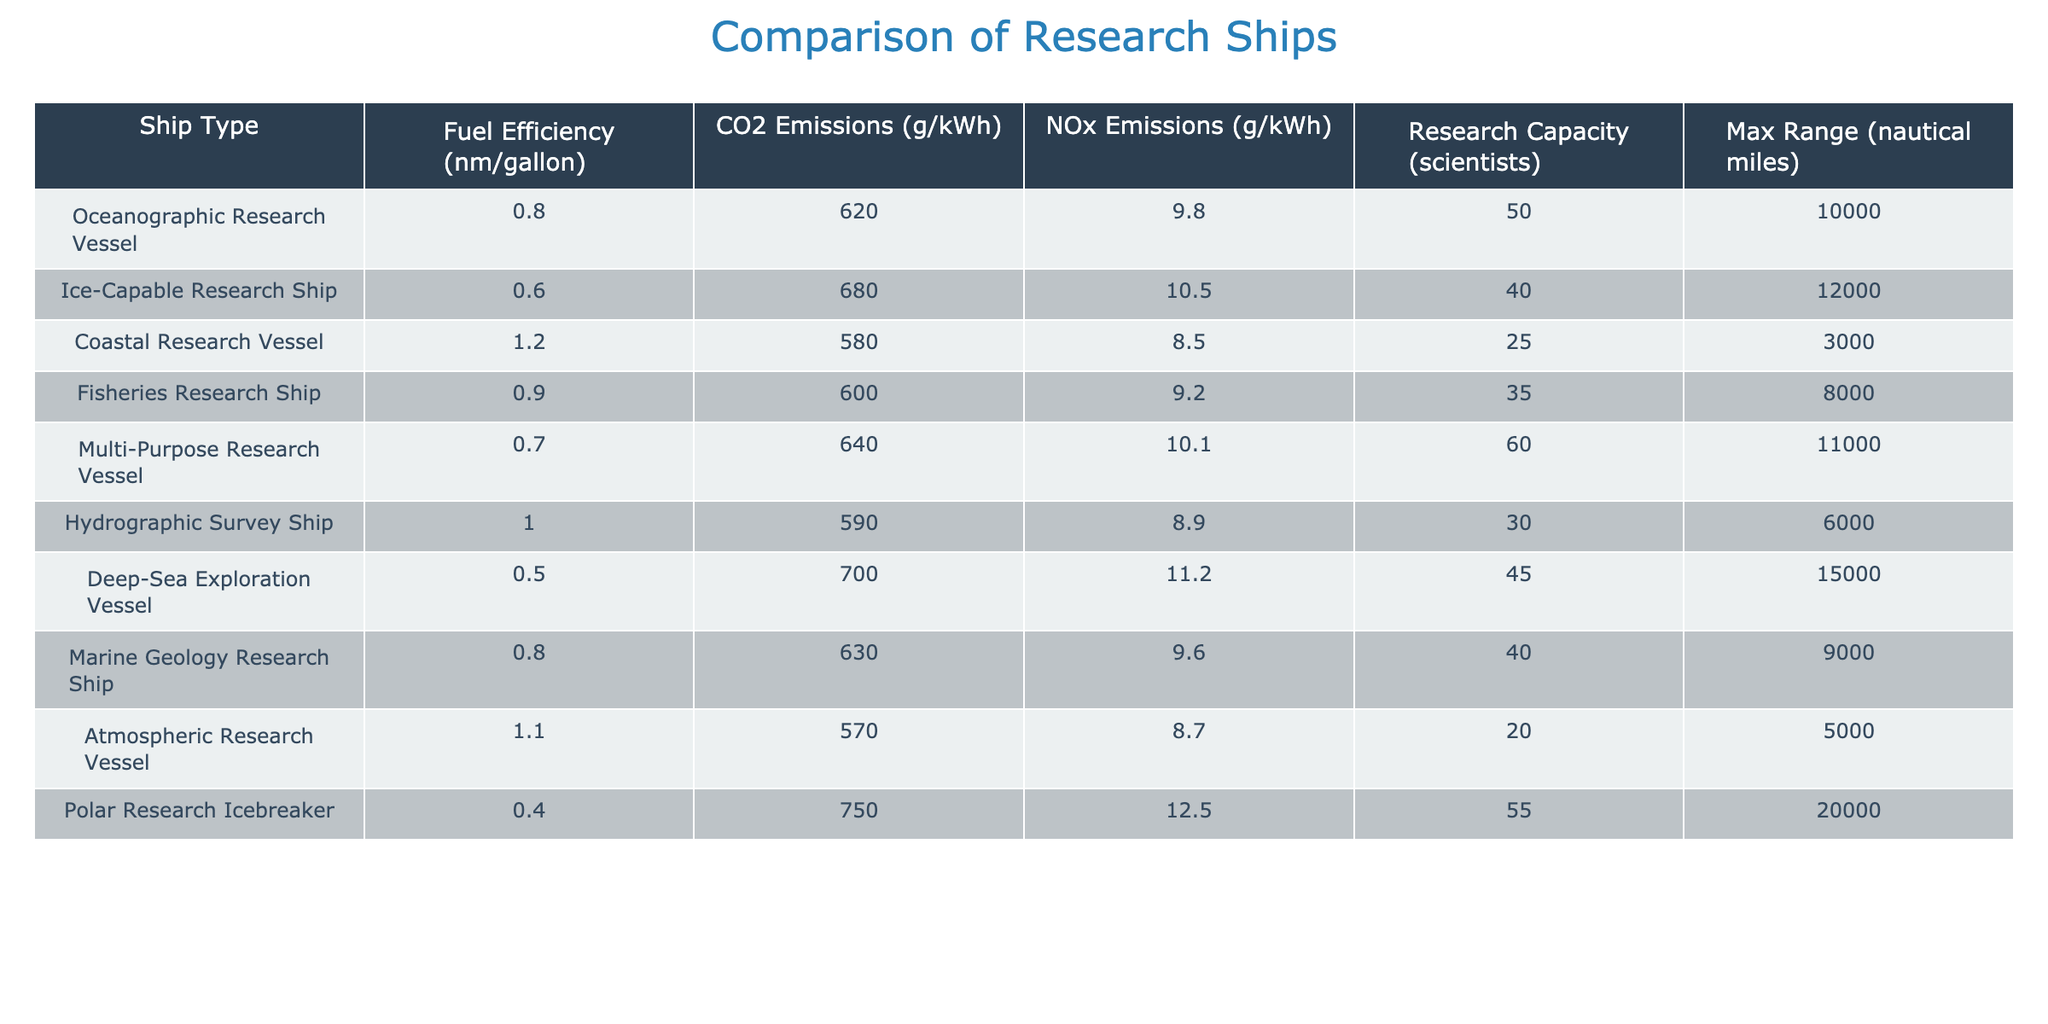What is the fuel efficiency of the Deep-Sea Exploration Vessel? The table indicates that the fuel efficiency of the Deep-Sea Exploration Vessel is 0.5 nm/gallon.
Answer: 0.5 nm/gallon Which research ship has the highest CO2 emissions? Upon checking the CO2 emissions column, the Polar Research Icebreaker has the highest emissions at 750 g/kWh.
Answer: Polar Research Icebreaker How many scientists can be accommodated in the Ice-Capable Research Ship? The table states that the Ice-Capable Research Ship can accommodate 40 scientists.
Answer: 40 scientists What is the average fuel efficiency of all the research ships? Adding the fuel efficiencies (0.8 + 0.6 + 1.2 + 0.9 + 0.7 + 1.0 + 0.5 + 0.8 + 1.1 + 0.4 = 7.0) and dividing by the number of ships (10) gives an average of 0.7 nm/gallon.
Answer: 0.7 nm/gallon Is there a research ship that has no NOx emissions recorded? The NOx emissions column shows that all research ships have recorded emissions greater than zero; hence, no ship has zero NOx emissions.
Answer: No Which research vessel has the lowest fuel efficiency? By examining the fuel efficiency values, the Deep-Sea Exploration Vessel shows the lowest at 0.5 nm/gallon.
Answer: Deep-Sea Exploration Vessel What is the total capacity for scientists on all the ships combined? Calculating the total capacity involves summing the research capacities (50 + 40 + 25 + 35 + 60 + 30 + 45 + 40 + 20 + 55 = 400). Therefore, the total capacity is 400 scientists.
Answer: 400 scientists Which ship can travel the maximum distance? The max range column indicates that the Polar Research Icebreaker can travel the furthest, with a maximum range of 20,000 nautical miles.
Answer: Polar Research Icebreaker If we compare the fuel efficiency and CO2 emissions, which ship is the most efficient in terms of low emissions relative to fuel efficiency? The Atmospheric Research Vessel has a fuel efficiency of 1.1 nm/gallon and CO2 emissions of 570 g/kWh. Comparing these values while considering the emissions relative to the fuel efficiency suggests it is efficient overall.
Answer: Atmospheric Research Vessel What is the difference in maximum range between Coastal Research Vessel and the Deep-Sea Exploration Vessel? The Coastal Research Vessel has a maximum range of 3,000 nautical miles, while the Deep-Sea Exploration Vessel has a maximum range of 15,000 nautical miles. The difference is 15,000 - 3,000 = 12,000 nautical miles.
Answer: 12,000 nautical miles 